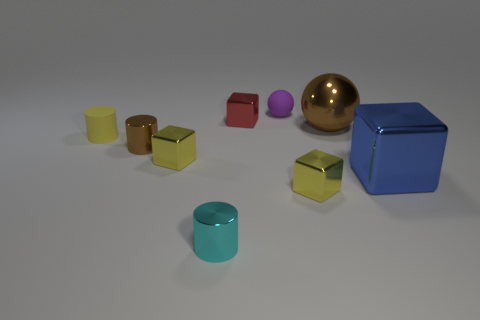How many yellow blocks must be subtracted to get 1 yellow blocks? 1 Subtract all cylinders. How many objects are left? 6 Subtract all small gray matte things. Subtract all rubber spheres. How many objects are left? 8 Add 8 blue shiny blocks. How many blue shiny blocks are left? 9 Add 3 small cyan metal things. How many small cyan metal things exist? 4 Subtract 0 gray blocks. How many objects are left? 9 